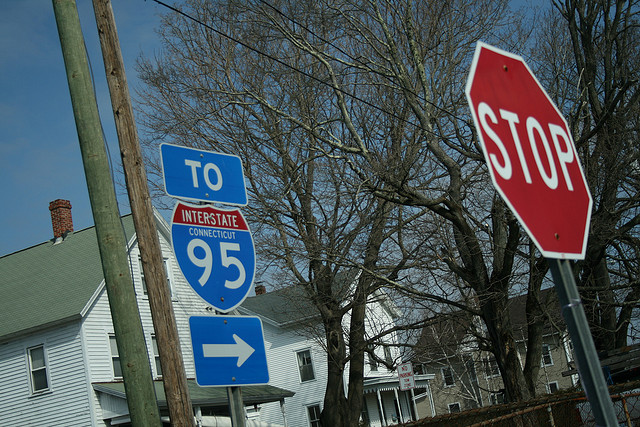Identify the text displayed in this image. TO INTERSTATE CONNECTICUT 95 STOP INTERSTATE 